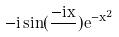Convert formula to latex. <formula><loc_0><loc_0><loc_500><loc_500>- i \sin ( \frac { - i x } { } ) e ^ { - x ^ { 2 } }</formula> 